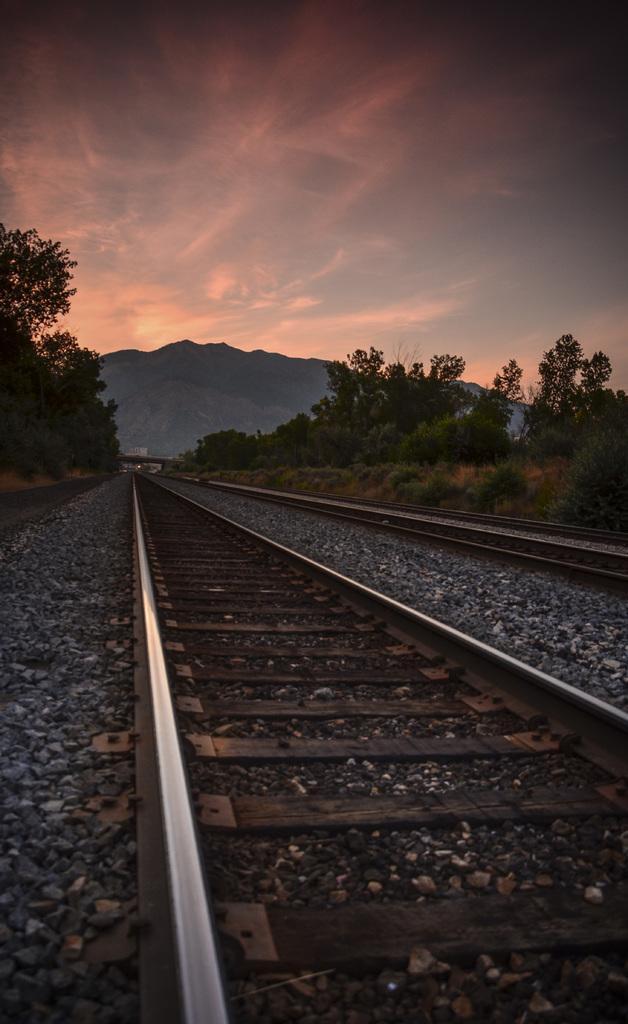In one or two sentences, can you explain what this image depicts? In this picture we can see there are railway tracks, stones, trees, a hill and the sky. 